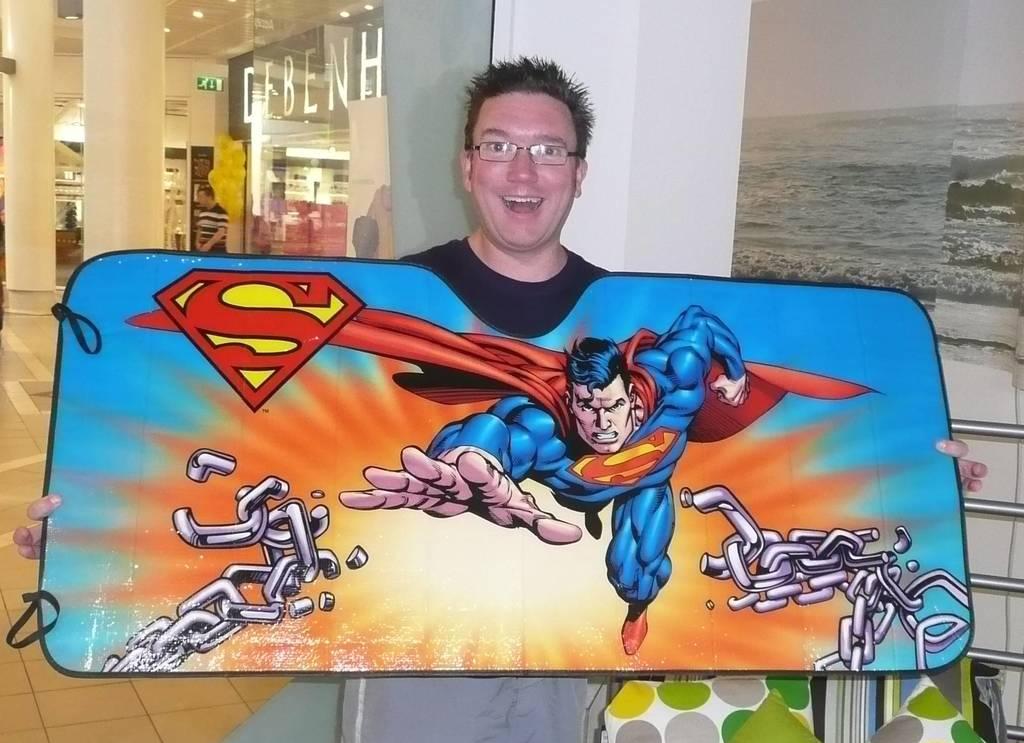Please provide a concise description of this image. In the picture we can see man wearing black color T-shirt, spectacles holding some board in his hands which is painted, we can see image of superman and in the background there is glass wall, there are some pillars and a person standing. 